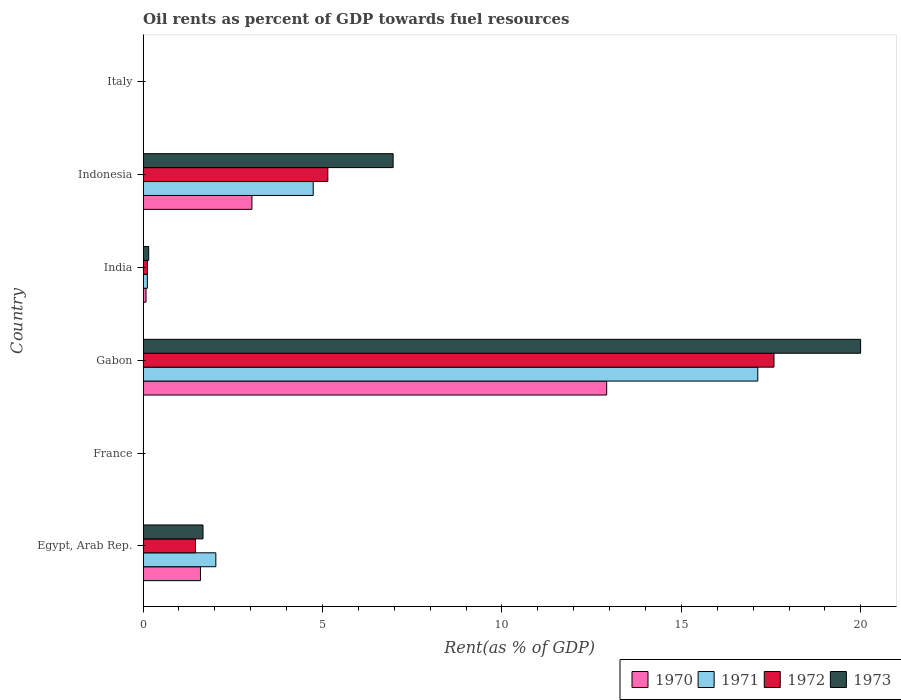How many groups of bars are there?
Your answer should be compact. 6. Are the number of bars on each tick of the Y-axis equal?
Your response must be concise. Yes. How many bars are there on the 3rd tick from the top?
Your answer should be very brief. 4. How many bars are there on the 6th tick from the bottom?
Offer a terse response. 4. What is the oil rent in 1970 in France?
Provide a succinct answer. 0.01. Across all countries, what is the maximum oil rent in 1971?
Your answer should be compact. 17.13. Across all countries, what is the minimum oil rent in 1970?
Give a very brief answer. 0.01. In which country was the oil rent in 1971 maximum?
Your answer should be very brief. Gabon. What is the total oil rent in 1971 in the graph?
Provide a short and direct response. 24.04. What is the difference between the oil rent in 1970 in France and that in Gabon?
Provide a succinct answer. -12.91. What is the difference between the oil rent in 1970 in Egypt, Arab Rep. and the oil rent in 1972 in Italy?
Offer a terse response. 1.59. What is the average oil rent in 1970 per country?
Your answer should be compact. 2.94. What is the difference between the oil rent in 1972 and oil rent in 1970 in Indonesia?
Make the answer very short. 2.11. What is the ratio of the oil rent in 1972 in Egypt, Arab Rep. to that in France?
Ensure brevity in your answer.  171.93. Is the oil rent in 1970 in India less than that in Indonesia?
Provide a succinct answer. Yes. Is the difference between the oil rent in 1972 in Egypt, Arab Rep. and France greater than the difference between the oil rent in 1970 in Egypt, Arab Rep. and France?
Offer a very short reply. No. What is the difference between the highest and the second highest oil rent in 1973?
Provide a short and direct response. 13.03. What is the difference between the highest and the lowest oil rent in 1970?
Your answer should be very brief. 12.91. What does the 4th bar from the top in Egypt, Arab Rep. represents?
Offer a terse response. 1970. Is it the case that in every country, the sum of the oil rent in 1970 and oil rent in 1971 is greater than the oil rent in 1972?
Your answer should be compact. Yes. Are all the bars in the graph horizontal?
Keep it short and to the point. Yes. How many countries are there in the graph?
Give a very brief answer. 6. What is the difference between two consecutive major ticks on the X-axis?
Ensure brevity in your answer.  5. Does the graph contain grids?
Provide a succinct answer. No. How many legend labels are there?
Your answer should be compact. 4. How are the legend labels stacked?
Your response must be concise. Horizontal. What is the title of the graph?
Your response must be concise. Oil rents as percent of GDP towards fuel resources. What is the label or title of the X-axis?
Your answer should be very brief. Rent(as % of GDP). What is the label or title of the Y-axis?
Provide a succinct answer. Country. What is the Rent(as % of GDP) of 1970 in Egypt, Arab Rep.?
Offer a very short reply. 1.6. What is the Rent(as % of GDP) in 1971 in Egypt, Arab Rep.?
Provide a short and direct response. 2.03. What is the Rent(as % of GDP) of 1972 in Egypt, Arab Rep.?
Make the answer very short. 1.46. What is the Rent(as % of GDP) in 1973 in Egypt, Arab Rep.?
Give a very brief answer. 1.67. What is the Rent(as % of GDP) of 1970 in France?
Ensure brevity in your answer.  0.01. What is the Rent(as % of GDP) in 1971 in France?
Offer a very short reply. 0.01. What is the Rent(as % of GDP) in 1972 in France?
Your response must be concise. 0.01. What is the Rent(as % of GDP) of 1973 in France?
Make the answer very short. 0.01. What is the Rent(as % of GDP) of 1970 in Gabon?
Provide a succinct answer. 12.92. What is the Rent(as % of GDP) in 1971 in Gabon?
Your answer should be compact. 17.13. What is the Rent(as % of GDP) in 1972 in Gabon?
Make the answer very short. 17.58. What is the Rent(as % of GDP) of 1973 in Gabon?
Give a very brief answer. 19.99. What is the Rent(as % of GDP) in 1970 in India?
Offer a very short reply. 0.08. What is the Rent(as % of GDP) of 1971 in India?
Ensure brevity in your answer.  0.12. What is the Rent(as % of GDP) of 1972 in India?
Provide a succinct answer. 0.12. What is the Rent(as % of GDP) in 1973 in India?
Make the answer very short. 0.16. What is the Rent(as % of GDP) in 1970 in Indonesia?
Offer a terse response. 3.03. What is the Rent(as % of GDP) of 1971 in Indonesia?
Offer a terse response. 4.74. What is the Rent(as % of GDP) of 1972 in Indonesia?
Provide a succinct answer. 5.15. What is the Rent(as % of GDP) of 1973 in Indonesia?
Your answer should be compact. 6.97. What is the Rent(as % of GDP) of 1970 in Italy?
Make the answer very short. 0.01. What is the Rent(as % of GDP) in 1971 in Italy?
Ensure brevity in your answer.  0.01. What is the Rent(as % of GDP) of 1972 in Italy?
Your answer should be compact. 0.01. What is the Rent(as % of GDP) of 1973 in Italy?
Keep it short and to the point. 0.01. Across all countries, what is the maximum Rent(as % of GDP) in 1970?
Keep it short and to the point. 12.92. Across all countries, what is the maximum Rent(as % of GDP) in 1971?
Provide a short and direct response. 17.13. Across all countries, what is the maximum Rent(as % of GDP) of 1972?
Offer a terse response. 17.58. Across all countries, what is the maximum Rent(as % of GDP) in 1973?
Provide a succinct answer. 19.99. Across all countries, what is the minimum Rent(as % of GDP) in 1970?
Your response must be concise. 0.01. Across all countries, what is the minimum Rent(as % of GDP) of 1971?
Your answer should be compact. 0.01. Across all countries, what is the minimum Rent(as % of GDP) of 1972?
Offer a terse response. 0.01. Across all countries, what is the minimum Rent(as % of GDP) of 1973?
Keep it short and to the point. 0.01. What is the total Rent(as % of GDP) of 1970 in the graph?
Give a very brief answer. 17.66. What is the total Rent(as % of GDP) of 1971 in the graph?
Offer a very short reply. 24.04. What is the total Rent(as % of GDP) in 1972 in the graph?
Give a very brief answer. 24.33. What is the total Rent(as % of GDP) of 1973 in the graph?
Make the answer very short. 28.81. What is the difference between the Rent(as % of GDP) of 1970 in Egypt, Arab Rep. and that in France?
Your answer should be compact. 1.59. What is the difference between the Rent(as % of GDP) of 1971 in Egypt, Arab Rep. and that in France?
Keep it short and to the point. 2.02. What is the difference between the Rent(as % of GDP) of 1972 in Egypt, Arab Rep. and that in France?
Your answer should be very brief. 1.45. What is the difference between the Rent(as % of GDP) in 1973 in Egypt, Arab Rep. and that in France?
Your answer should be very brief. 1.66. What is the difference between the Rent(as % of GDP) of 1970 in Egypt, Arab Rep. and that in Gabon?
Your response must be concise. -11.32. What is the difference between the Rent(as % of GDP) of 1971 in Egypt, Arab Rep. and that in Gabon?
Ensure brevity in your answer.  -15.1. What is the difference between the Rent(as % of GDP) of 1972 in Egypt, Arab Rep. and that in Gabon?
Keep it short and to the point. -16.12. What is the difference between the Rent(as % of GDP) in 1973 in Egypt, Arab Rep. and that in Gabon?
Ensure brevity in your answer.  -18.32. What is the difference between the Rent(as % of GDP) in 1970 in Egypt, Arab Rep. and that in India?
Your answer should be compact. 1.52. What is the difference between the Rent(as % of GDP) in 1971 in Egypt, Arab Rep. and that in India?
Provide a succinct answer. 1.91. What is the difference between the Rent(as % of GDP) in 1972 in Egypt, Arab Rep. and that in India?
Provide a short and direct response. 1.34. What is the difference between the Rent(as % of GDP) in 1973 in Egypt, Arab Rep. and that in India?
Ensure brevity in your answer.  1.51. What is the difference between the Rent(as % of GDP) in 1970 in Egypt, Arab Rep. and that in Indonesia?
Provide a succinct answer. -1.43. What is the difference between the Rent(as % of GDP) of 1971 in Egypt, Arab Rep. and that in Indonesia?
Your response must be concise. -2.71. What is the difference between the Rent(as % of GDP) in 1972 in Egypt, Arab Rep. and that in Indonesia?
Provide a short and direct response. -3.69. What is the difference between the Rent(as % of GDP) in 1973 in Egypt, Arab Rep. and that in Indonesia?
Make the answer very short. -5.3. What is the difference between the Rent(as % of GDP) in 1970 in Egypt, Arab Rep. and that in Italy?
Give a very brief answer. 1.59. What is the difference between the Rent(as % of GDP) in 1971 in Egypt, Arab Rep. and that in Italy?
Ensure brevity in your answer.  2.02. What is the difference between the Rent(as % of GDP) of 1972 in Egypt, Arab Rep. and that in Italy?
Provide a succinct answer. 1.45. What is the difference between the Rent(as % of GDP) of 1973 in Egypt, Arab Rep. and that in Italy?
Provide a short and direct response. 1.66. What is the difference between the Rent(as % of GDP) in 1970 in France and that in Gabon?
Ensure brevity in your answer.  -12.91. What is the difference between the Rent(as % of GDP) in 1971 in France and that in Gabon?
Provide a short and direct response. -17.12. What is the difference between the Rent(as % of GDP) in 1972 in France and that in Gabon?
Keep it short and to the point. -17.57. What is the difference between the Rent(as % of GDP) in 1973 in France and that in Gabon?
Your answer should be compact. -19.98. What is the difference between the Rent(as % of GDP) of 1970 in France and that in India?
Keep it short and to the point. -0.07. What is the difference between the Rent(as % of GDP) of 1971 in France and that in India?
Give a very brief answer. -0.11. What is the difference between the Rent(as % of GDP) in 1972 in France and that in India?
Make the answer very short. -0.11. What is the difference between the Rent(as % of GDP) in 1973 in France and that in India?
Provide a short and direct response. -0.15. What is the difference between the Rent(as % of GDP) of 1970 in France and that in Indonesia?
Your answer should be compact. -3.02. What is the difference between the Rent(as % of GDP) in 1971 in France and that in Indonesia?
Provide a short and direct response. -4.73. What is the difference between the Rent(as % of GDP) of 1972 in France and that in Indonesia?
Offer a very short reply. -5.14. What is the difference between the Rent(as % of GDP) of 1973 in France and that in Indonesia?
Make the answer very short. -6.96. What is the difference between the Rent(as % of GDP) in 1970 in France and that in Italy?
Your answer should be compact. 0. What is the difference between the Rent(as % of GDP) of 1971 in France and that in Italy?
Keep it short and to the point. 0. What is the difference between the Rent(as % of GDP) of 1972 in France and that in Italy?
Your response must be concise. -0. What is the difference between the Rent(as % of GDP) in 1973 in France and that in Italy?
Your response must be concise. -0. What is the difference between the Rent(as % of GDP) of 1970 in Gabon and that in India?
Your response must be concise. 12.84. What is the difference between the Rent(as % of GDP) in 1971 in Gabon and that in India?
Provide a short and direct response. 17.01. What is the difference between the Rent(as % of GDP) in 1972 in Gabon and that in India?
Keep it short and to the point. 17.46. What is the difference between the Rent(as % of GDP) of 1973 in Gabon and that in India?
Your answer should be compact. 19.84. What is the difference between the Rent(as % of GDP) in 1970 in Gabon and that in Indonesia?
Your response must be concise. 9.88. What is the difference between the Rent(as % of GDP) in 1971 in Gabon and that in Indonesia?
Offer a very short reply. 12.39. What is the difference between the Rent(as % of GDP) of 1972 in Gabon and that in Indonesia?
Give a very brief answer. 12.43. What is the difference between the Rent(as % of GDP) in 1973 in Gabon and that in Indonesia?
Your response must be concise. 13.03. What is the difference between the Rent(as % of GDP) in 1970 in Gabon and that in Italy?
Your answer should be compact. 12.91. What is the difference between the Rent(as % of GDP) in 1971 in Gabon and that in Italy?
Your answer should be compact. 17.12. What is the difference between the Rent(as % of GDP) in 1972 in Gabon and that in Italy?
Your answer should be very brief. 17.57. What is the difference between the Rent(as % of GDP) of 1973 in Gabon and that in Italy?
Your answer should be very brief. 19.98. What is the difference between the Rent(as % of GDP) in 1970 in India and that in Indonesia?
Your response must be concise. -2.95. What is the difference between the Rent(as % of GDP) in 1971 in India and that in Indonesia?
Make the answer very short. -4.62. What is the difference between the Rent(as % of GDP) in 1972 in India and that in Indonesia?
Make the answer very short. -5.03. What is the difference between the Rent(as % of GDP) in 1973 in India and that in Indonesia?
Your answer should be very brief. -6.81. What is the difference between the Rent(as % of GDP) in 1970 in India and that in Italy?
Ensure brevity in your answer.  0.07. What is the difference between the Rent(as % of GDP) in 1971 in India and that in Italy?
Your answer should be compact. 0.11. What is the difference between the Rent(as % of GDP) of 1972 in India and that in Italy?
Provide a succinct answer. 0.11. What is the difference between the Rent(as % of GDP) of 1973 in India and that in Italy?
Make the answer very short. 0.15. What is the difference between the Rent(as % of GDP) of 1970 in Indonesia and that in Italy?
Provide a short and direct response. 3.02. What is the difference between the Rent(as % of GDP) of 1971 in Indonesia and that in Italy?
Ensure brevity in your answer.  4.73. What is the difference between the Rent(as % of GDP) of 1972 in Indonesia and that in Italy?
Provide a short and direct response. 5.14. What is the difference between the Rent(as % of GDP) in 1973 in Indonesia and that in Italy?
Provide a short and direct response. 6.96. What is the difference between the Rent(as % of GDP) in 1970 in Egypt, Arab Rep. and the Rent(as % of GDP) in 1971 in France?
Give a very brief answer. 1.59. What is the difference between the Rent(as % of GDP) of 1970 in Egypt, Arab Rep. and the Rent(as % of GDP) of 1972 in France?
Your answer should be compact. 1.59. What is the difference between the Rent(as % of GDP) in 1970 in Egypt, Arab Rep. and the Rent(as % of GDP) in 1973 in France?
Give a very brief answer. 1.59. What is the difference between the Rent(as % of GDP) in 1971 in Egypt, Arab Rep. and the Rent(as % of GDP) in 1972 in France?
Provide a succinct answer. 2.02. What is the difference between the Rent(as % of GDP) in 1971 in Egypt, Arab Rep. and the Rent(as % of GDP) in 1973 in France?
Your answer should be compact. 2.02. What is the difference between the Rent(as % of GDP) in 1972 in Egypt, Arab Rep. and the Rent(as % of GDP) in 1973 in France?
Make the answer very short. 1.45. What is the difference between the Rent(as % of GDP) of 1970 in Egypt, Arab Rep. and the Rent(as % of GDP) of 1971 in Gabon?
Keep it short and to the point. -15.53. What is the difference between the Rent(as % of GDP) of 1970 in Egypt, Arab Rep. and the Rent(as % of GDP) of 1972 in Gabon?
Keep it short and to the point. -15.98. What is the difference between the Rent(as % of GDP) of 1970 in Egypt, Arab Rep. and the Rent(as % of GDP) of 1973 in Gabon?
Your answer should be very brief. -18.39. What is the difference between the Rent(as % of GDP) in 1971 in Egypt, Arab Rep. and the Rent(as % of GDP) in 1972 in Gabon?
Ensure brevity in your answer.  -15.55. What is the difference between the Rent(as % of GDP) of 1971 in Egypt, Arab Rep. and the Rent(as % of GDP) of 1973 in Gabon?
Provide a short and direct response. -17.97. What is the difference between the Rent(as % of GDP) in 1972 in Egypt, Arab Rep. and the Rent(as % of GDP) in 1973 in Gabon?
Provide a succinct answer. -18.53. What is the difference between the Rent(as % of GDP) in 1970 in Egypt, Arab Rep. and the Rent(as % of GDP) in 1971 in India?
Ensure brevity in your answer.  1.48. What is the difference between the Rent(as % of GDP) in 1970 in Egypt, Arab Rep. and the Rent(as % of GDP) in 1972 in India?
Provide a short and direct response. 1.48. What is the difference between the Rent(as % of GDP) in 1970 in Egypt, Arab Rep. and the Rent(as % of GDP) in 1973 in India?
Offer a terse response. 1.44. What is the difference between the Rent(as % of GDP) in 1971 in Egypt, Arab Rep. and the Rent(as % of GDP) in 1972 in India?
Your answer should be very brief. 1.91. What is the difference between the Rent(as % of GDP) in 1971 in Egypt, Arab Rep. and the Rent(as % of GDP) in 1973 in India?
Your answer should be very brief. 1.87. What is the difference between the Rent(as % of GDP) of 1972 in Egypt, Arab Rep. and the Rent(as % of GDP) of 1973 in India?
Ensure brevity in your answer.  1.3. What is the difference between the Rent(as % of GDP) in 1970 in Egypt, Arab Rep. and the Rent(as % of GDP) in 1971 in Indonesia?
Give a very brief answer. -3.14. What is the difference between the Rent(as % of GDP) of 1970 in Egypt, Arab Rep. and the Rent(as % of GDP) of 1972 in Indonesia?
Your answer should be very brief. -3.55. What is the difference between the Rent(as % of GDP) in 1970 in Egypt, Arab Rep. and the Rent(as % of GDP) in 1973 in Indonesia?
Ensure brevity in your answer.  -5.37. What is the difference between the Rent(as % of GDP) of 1971 in Egypt, Arab Rep. and the Rent(as % of GDP) of 1972 in Indonesia?
Your response must be concise. -3.12. What is the difference between the Rent(as % of GDP) in 1971 in Egypt, Arab Rep. and the Rent(as % of GDP) in 1973 in Indonesia?
Give a very brief answer. -4.94. What is the difference between the Rent(as % of GDP) in 1972 in Egypt, Arab Rep. and the Rent(as % of GDP) in 1973 in Indonesia?
Your answer should be very brief. -5.51. What is the difference between the Rent(as % of GDP) in 1970 in Egypt, Arab Rep. and the Rent(as % of GDP) in 1971 in Italy?
Ensure brevity in your answer.  1.59. What is the difference between the Rent(as % of GDP) in 1970 in Egypt, Arab Rep. and the Rent(as % of GDP) in 1972 in Italy?
Give a very brief answer. 1.59. What is the difference between the Rent(as % of GDP) of 1970 in Egypt, Arab Rep. and the Rent(as % of GDP) of 1973 in Italy?
Offer a very short reply. 1.59. What is the difference between the Rent(as % of GDP) of 1971 in Egypt, Arab Rep. and the Rent(as % of GDP) of 1972 in Italy?
Offer a terse response. 2.02. What is the difference between the Rent(as % of GDP) of 1971 in Egypt, Arab Rep. and the Rent(as % of GDP) of 1973 in Italy?
Your response must be concise. 2.02. What is the difference between the Rent(as % of GDP) of 1972 in Egypt, Arab Rep. and the Rent(as % of GDP) of 1973 in Italy?
Make the answer very short. 1.45. What is the difference between the Rent(as % of GDP) in 1970 in France and the Rent(as % of GDP) in 1971 in Gabon?
Offer a very short reply. -17.12. What is the difference between the Rent(as % of GDP) of 1970 in France and the Rent(as % of GDP) of 1972 in Gabon?
Ensure brevity in your answer.  -17.57. What is the difference between the Rent(as % of GDP) of 1970 in France and the Rent(as % of GDP) of 1973 in Gabon?
Your answer should be compact. -19.98. What is the difference between the Rent(as % of GDP) in 1971 in France and the Rent(as % of GDP) in 1972 in Gabon?
Ensure brevity in your answer.  -17.57. What is the difference between the Rent(as % of GDP) of 1971 in France and the Rent(as % of GDP) of 1973 in Gabon?
Your response must be concise. -19.98. What is the difference between the Rent(as % of GDP) of 1972 in France and the Rent(as % of GDP) of 1973 in Gabon?
Ensure brevity in your answer.  -19.99. What is the difference between the Rent(as % of GDP) in 1970 in France and the Rent(as % of GDP) in 1971 in India?
Make the answer very short. -0.11. What is the difference between the Rent(as % of GDP) in 1970 in France and the Rent(as % of GDP) in 1972 in India?
Give a very brief answer. -0.11. What is the difference between the Rent(as % of GDP) of 1970 in France and the Rent(as % of GDP) of 1973 in India?
Your answer should be compact. -0.15. What is the difference between the Rent(as % of GDP) in 1971 in France and the Rent(as % of GDP) in 1972 in India?
Your answer should be very brief. -0.11. What is the difference between the Rent(as % of GDP) in 1971 in France and the Rent(as % of GDP) in 1973 in India?
Offer a terse response. -0.14. What is the difference between the Rent(as % of GDP) of 1972 in France and the Rent(as % of GDP) of 1973 in India?
Your response must be concise. -0.15. What is the difference between the Rent(as % of GDP) of 1970 in France and the Rent(as % of GDP) of 1971 in Indonesia?
Ensure brevity in your answer.  -4.73. What is the difference between the Rent(as % of GDP) in 1970 in France and the Rent(as % of GDP) in 1972 in Indonesia?
Offer a very short reply. -5.14. What is the difference between the Rent(as % of GDP) in 1970 in France and the Rent(as % of GDP) in 1973 in Indonesia?
Provide a short and direct response. -6.96. What is the difference between the Rent(as % of GDP) in 1971 in France and the Rent(as % of GDP) in 1972 in Indonesia?
Your answer should be very brief. -5.14. What is the difference between the Rent(as % of GDP) in 1971 in France and the Rent(as % of GDP) in 1973 in Indonesia?
Give a very brief answer. -6.96. What is the difference between the Rent(as % of GDP) of 1972 in France and the Rent(as % of GDP) of 1973 in Indonesia?
Provide a short and direct response. -6.96. What is the difference between the Rent(as % of GDP) of 1970 in France and the Rent(as % of GDP) of 1971 in Italy?
Your answer should be compact. -0. What is the difference between the Rent(as % of GDP) in 1970 in France and the Rent(as % of GDP) in 1972 in Italy?
Offer a terse response. 0. What is the difference between the Rent(as % of GDP) in 1970 in France and the Rent(as % of GDP) in 1973 in Italy?
Keep it short and to the point. 0. What is the difference between the Rent(as % of GDP) of 1971 in France and the Rent(as % of GDP) of 1972 in Italy?
Your response must be concise. 0. What is the difference between the Rent(as % of GDP) in 1971 in France and the Rent(as % of GDP) in 1973 in Italy?
Give a very brief answer. 0. What is the difference between the Rent(as % of GDP) in 1972 in France and the Rent(as % of GDP) in 1973 in Italy?
Provide a succinct answer. -0. What is the difference between the Rent(as % of GDP) of 1970 in Gabon and the Rent(as % of GDP) of 1971 in India?
Offer a terse response. 12.8. What is the difference between the Rent(as % of GDP) of 1970 in Gabon and the Rent(as % of GDP) of 1972 in India?
Offer a terse response. 12.8. What is the difference between the Rent(as % of GDP) of 1970 in Gabon and the Rent(as % of GDP) of 1973 in India?
Offer a very short reply. 12.76. What is the difference between the Rent(as % of GDP) in 1971 in Gabon and the Rent(as % of GDP) in 1972 in India?
Provide a short and direct response. 17.01. What is the difference between the Rent(as % of GDP) in 1971 in Gabon and the Rent(as % of GDP) in 1973 in India?
Make the answer very short. 16.97. What is the difference between the Rent(as % of GDP) in 1972 in Gabon and the Rent(as % of GDP) in 1973 in India?
Ensure brevity in your answer.  17.42. What is the difference between the Rent(as % of GDP) in 1970 in Gabon and the Rent(as % of GDP) in 1971 in Indonesia?
Offer a terse response. 8.18. What is the difference between the Rent(as % of GDP) of 1970 in Gabon and the Rent(as % of GDP) of 1972 in Indonesia?
Offer a terse response. 7.77. What is the difference between the Rent(as % of GDP) in 1970 in Gabon and the Rent(as % of GDP) in 1973 in Indonesia?
Provide a short and direct response. 5.95. What is the difference between the Rent(as % of GDP) of 1971 in Gabon and the Rent(as % of GDP) of 1972 in Indonesia?
Provide a short and direct response. 11.98. What is the difference between the Rent(as % of GDP) in 1971 in Gabon and the Rent(as % of GDP) in 1973 in Indonesia?
Provide a succinct answer. 10.16. What is the difference between the Rent(as % of GDP) of 1972 in Gabon and the Rent(as % of GDP) of 1973 in Indonesia?
Offer a very short reply. 10.61. What is the difference between the Rent(as % of GDP) of 1970 in Gabon and the Rent(as % of GDP) of 1971 in Italy?
Offer a terse response. 12.91. What is the difference between the Rent(as % of GDP) of 1970 in Gabon and the Rent(as % of GDP) of 1972 in Italy?
Provide a short and direct response. 12.91. What is the difference between the Rent(as % of GDP) in 1970 in Gabon and the Rent(as % of GDP) in 1973 in Italy?
Ensure brevity in your answer.  12.91. What is the difference between the Rent(as % of GDP) of 1971 in Gabon and the Rent(as % of GDP) of 1972 in Italy?
Ensure brevity in your answer.  17.12. What is the difference between the Rent(as % of GDP) in 1971 in Gabon and the Rent(as % of GDP) in 1973 in Italy?
Provide a short and direct response. 17.12. What is the difference between the Rent(as % of GDP) of 1972 in Gabon and the Rent(as % of GDP) of 1973 in Italy?
Provide a short and direct response. 17.57. What is the difference between the Rent(as % of GDP) of 1970 in India and the Rent(as % of GDP) of 1971 in Indonesia?
Give a very brief answer. -4.66. What is the difference between the Rent(as % of GDP) of 1970 in India and the Rent(as % of GDP) of 1972 in Indonesia?
Make the answer very short. -5.07. What is the difference between the Rent(as % of GDP) of 1970 in India and the Rent(as % of GDP) of 1973 in Indonesia?
Provide a succinct answer. -6.89. What is the difference between the Rent(as % of GDP) of 1971 in India and the Rent(as % of GDP) of 1972 in Indonesia?
Ensure brevity in your answer.  -5.03. What is the difference between the Rent(as % of GDP) of 1971 in India and the Rent(as % of GDP) of 1973 in Indonesia?
Offer a terse response. -6.85. What is the difference between the Rent(as % of GDP) of 1972 in India and the Rent(as % of GDP) of 1973 in Indonesia?
Your answer should be compact. -6.85. What is the difference between the Rent(as % of GDP) of 1970 in India and the Rent(as % of GDP) of 1971 in Italy?
Your response must be concise. 0.07. What is the difference between the Rent(as % of GDP) in 1970 in India and the Rent(as % of GDP) in 1972 in Italy?
Offer a very short reply. 0.07. What is the difference between the Rent(as % of GDP) of 1970 in India and the Rent(as % of GDP) of 1973 in Italy?
Your answer should be very brief. 0.07. What is the difference between the Rent(as % of GDP) in 1971 in India and the Rent(as % of GDP) in 1972 in Italy?
Your answer should be very brief. 0.11. What is the difference between the Rent(as % of GDP) of 1971 in India and the Rent(as % of GDP) of 1973 in Italy?
Ensure brevity in your answer.  0.11. What is the difference between the Rent(as % of GDP) of 1972 in India and the Rent(as % of GDP) of 1973 in Italy?
Offer a terse response. 0.11. What is the difference between the Rent(as % of GDP) of 1970 in Indonesia and the Rent(as % of GDP) of 1971 in Italy?
Offer a very short reply. 3.02. What is the difference between the Rent(as % of GDP) of 1970 in Indonesia and the Rent(as % of GDP) of 1972 in Italy?
Ensure brevity in your answer.  3.02. What is the difference between the Rent(as % of GDP) of 1970 in Indonesia and the Rent(as % of GDP) of 1973 in Italy?
Provide a succinct answer. 3.02. What is the difference between the Rent(as % of GDP) in 1971 in Indonesia and the Rent(as % of GDP) in 1972 in Italy?
Give a very brief answer. 4.73. What is the difference between the Rent(as % of GDP) of 1971 in Indonesia and the Rent(as % of GDP) of 1973 in Italy?
Offer a terse response. 4.73. What is the difference between the Rent(as % of GDP) of 1972 in Indonesia and the Rent(as % of GDP) of 1973 in Italy?
Offer a terse response. 5.14. What is the average Rent(as % of GDP) of 1970 per country?
Offer a terse response. 2.94. What is the average Rent(as % of GDP) in 1971 per country?
Provide a succinct answer. 4.01. What is the average Rent(as % of GDP) of 1972 per country?
Keep it short and to the point. 4.05. What is the average Rent(as % of GDP) in 1973 per country?
Your answer should be very brief. 4.8. What is the difference between the Rent(as % of GDP) of 1970 and Rent(as % of GDP) of 1971 in Egypt, Arab Rep.?
Give a very brief answer. -0.43. What is the difference between the Rent(as % of GDP) of 1970 and Rent(as % of GDP) of 1972 in Egypt, Arab Rep.?
Make the answer very short. 0.14. What is the difference between the Rent(as % of GDP) in 1970 and Rent(as % of GDP) in 1973 in Egypt, Arab Rep.?
Your answer should be very brief. -0.07. What is the difference between the Rent(as % of GDP) in 1971 and Rent(as % of GDP) in 1972 in Egypt, Arab Rep.?
Your answer should be very brief. 0.57. What is the difference between the Rent(as % of GDP) in 1971 and Rent(as % of GDP) in 1973 in Egypt, Arab Rep.?
Offer a terse response. 0.36. What is the difference between the Rent(as % of GDP) in 1972 and Rent(as % of GDP) in 1973 in Egypt, Arab Rep.?
Provide a short and direct response. -0.21. What is the difference between the Rent(as % of GDP) in 1970 and Rent(as % of GDP) in 1971 in France?
Give a very brief answer. -0. What is the difference between the Rent(as % of GDP) in 1970 and Rent(as % of GDP) in 1972 in France?
Make the answer very short. 0. What is the difference between the Rent(as % of GDP) in 1970 and Rent(as % of GDP) in 1973 in France?
Your response must be concise. 0. What is the difference between the Rent(as % of GDP) in 1971 and Rent(as % of GDP) in 1972 in France?
Ensure brevity in your answer.  0. What is the difference between the Rent(as % of GDP) of 1971 and Rent(as % of GDP) of 1973 in France?
Provide a succinct answer. 0. What is the difference between the Rent(as % of GDP) in 1972 and Rent(as % of GDP) in 1973 in France?
Your answer should be very brief. -0. What is the difference between the Rent(as % of GDP) in 1970 and Rent(as % of GDP) in 1971 in Gabon?
Your response must be concise. -4.21. What is the difference between the Rent(as % of GDP) in 1970 and Rent(as % of GDP) in 1972 in Gabon?
Keep it short and to the point. -4.66. What is the difference between the Rent(as % of GDP) in 1970 and Rent(as % of GDP) in 1973 in Gabon?
Provide a succinct answer. -7.08. What is the difference between the Rent(as % of GDP) of 1971 and Rent(as % of GDP) of 1972 in Gabon?
Your answer should be compact. -0.45. What is the difference between the Rent(as % of GDP) in 1971 and Rent(as % of GDP) in 1973 in Gabon?
Your response must be concise. -2.87. What is the difference between the Rent(as % of GDP) in 1972 and Rent(as % of GDP) in 1973 in Gabon?
Your response must be concise. -2.41. What is the difference between the Rent(as % of GDP) of 1970 and Rent(as % of GDP) of 1971 in India?
Give a very brief answer. -0.04. What is the difference between the Rent(as % of GDP) of 1970 and Rent(as % of GDP) of 1972 in India?
Your response must be concise. -0.04. What is the difference between the Rent(as % of GDP) of 1970 and Rent(as % of GDP) of 1973 in India?
Keep it short and to the point. -0.07. What is the difference between the Rent(as % of GDP) in 1971 and Rent(as % of GDP) in 1972 in India?
Your answer should be very brief. -0. What is the difference between the Rent(as % of GDP) of 1971 and Rent(as % of GDP) of 1973 in India?
Provide a short and direct response. -0.04. What is the difference between the Rent(as % of GDP) of 1972 and Rent(as % of GDP) of 1973 in India?
Give a very brief answer. -0.04. What is the difference between the Rent(as % of GDP) in 1970 and Rent(as % of GDP) in 1971 in Indonesia?
Your answer should be very brief. -1.71. What is the difference between the Rent(as % of GDP) in 1970 and Rent(as % of GDP) in 1972 in Indonesia?
Keep it short and to the point. -2.11. What is the difference between the Rent(as % of GDP) of 1970 and Rent(as % of GDP) of 1973 in Indonesia?
Make the answer very short. -3.93. What is the difference between the Rent(as % of GDP) of 1971 and Rent(as % of GDP) of 1972 in Indonesia?
Make the answer very short. -0.41. What is the difference between the Rent(as % of GDP) in 1971 and Rent(as % of GDP) in 1973 in Indonesia?
Your response must be concise. -2.23. What is the difference between the Rent(as % of GDP) in 1972 and Rent(as % of GDP) in 1973 in Indonesia?
Your answer should be compact. -1.82. What is the difference between the Rent(as % of GDP) in 1970 and Rent(as % of GDP) in 1971 in Italy?
Provide a succinct answer. -0. What is the difference between the Rent(as % of GDP) in 1970 and Rent(as % of GDP) in 1972 in Italy?
Keep it short and to the point. 0. What is the difference between the Rent(as % of GDP) of 1970 and Rent(as % of GDP) of 1973 in Italy?
Offer a terse response. -0. What is the difference between the Rent(as % of GDP) in 1971 and Rent(as % of GDP) in 1972 in Italy?
Give a very brief answer. 0. What is the difference between the Rent(as % of GDP) in 1972 and Rent(as % of GDP) in 1973 in Italy?
Give a very brief answer. -0. What is the ratio of the Rent(as % of GDP) in 1970 in Egypt, Arab Rep. to that in France?
Your response must be concise. 139.1. What is the ratio of the Rent(as % of GDP) in 1971 in Egypt, Arab Rep. to that in France?
Make the answer very short. 164.4. What is the ratio of the Rent(as % of GDP) in 1972 in Egypt, Arab Rep. to that in France?
Offer a terse response. 171.93. What is the ratio of the Rent(as % of GDP) of 1973 in Egypt, Arab Rep. to that in France?
Offer a terse response. 189.03. What is the ratio of the Rent(as % of GDP) in 1970 in Egypt, Arab Rep. to that in Gabon?
Your response must be concise. 0.12. What is the ratio of the Rent(as % of GDP) in 1971 in Egypt, Arab Rep. to that in Gabon?
Provide a short and direct response. 0.12. What is the ratio of the Rent(as % of GDP) in 1972 in Egypt, Arab Rep. to that in Gabon?
Your answer should be compact. 0.08. What is the ratio of the Rent(as % of GDP) in 1973 in Egypt, Arab Rep. to that in Gabon?
Your answer should be very brief. 0.08. What is the ratio of the Rent(as % of GDP) in 1970 in Egypt, Arab Rep. to that in India?
Provide a short and direct response. 19.39. What is the ratio of the Rent(as % of GDP) of 1971 in Egypt, Arab Rep. to that in India?
Give a very brief answer. 16.93. What is the ratio of the Rent(as % of GDP) in 1972 in Egypt, Arab Rep. to that in India?
Ensure brevity in your answer.  12.16. What is the ratio of the Rent(as % of GDP) of 1973 in Egypt, Arab Rep. to that in India?
Your answer should be very brief. 10.63. What is the ratio of the Rent(as % of GDP) of 1970 in Egypt, Arab Rep. to that in Indonesia?
Provide a succinct answer. 0.53. What is the ratio of the Rent(as % of GDP) in 1971 in Egypt, Arab Rep. to that in Indonesia?
Provide a short and direct response. 0.43. What is the ratio of the Rent(as % of GDP) in 1972 in Egypt, Arab Rep. to that in Indonesia?
Give a very brief answer. 0.28. What is the ratio of the Rent(as % of GDP) of 1973 in Egypt, Arab Rep. to that in Indonesia?
Provide a succinct answer. 0.24. What is the ratio of the Rent(as % of GDP) in 1970 in Egypt, Arab Rep. to that in Italy?
Your answer should be very brief. 162.31. What is the ratio of the Rent(as % of GDP) in 1971 in Egypt, Arab Rep. to that in Italy?
Your answer should be compact. 173.07. What is the ratio of the Rent(as % of GDP) of 1972 in Egypt, Arab Rep. to that in Italy?
Offer a terse response. 157.02. What is the ratio of the Rent(as % of GDP) in 1973 in Egypt, Arab Rep. to that in Italy?
Offer a terse response. 149.13. What is the ratio of the Rent(as % of GDP) in 1970 in France to that in Gabon?
Ensure brevity in your answer.  0. What is the ratio of the Rent(as % of GDP) of 1971 in France to that in Gabon?
Provide a short and direct response. 0. What is the ratio of the Rent(as % of GDP) in 1972 in France to that in Gabon?
Provide a succinct answer. 0. What is the ratio of the Rent(as % of GDP) in 1970 in France to that in India?
Ensure brevity in your answer.  0.14. What is the ratio of the Rent(as % of GDP) of 1971 in France to that in India?
Ensure brevity in your answer.  0.1. What is the ratio of the Rent(as % of GDP) in 1972 in France to that in India?
Your response must be concise. 0.07. What is the ratio of the Rent(as % of GDP) of 1973 in France to that in India?
Ensure brevity in your answer.  0.06. What is the ratio of the Rent(as % of GDP) of 1970 in France to that in Indonesia?
Make the answer very short. 0. What is the ratio of the Rent(as % of GDP) of 1971 in France to that in Indonesia?
Your answer should be compact. 0. What is the ratio of the Rent(as % of GDP) of 1972 in France to that in Indonesia?
Your response must be concise. 0. What is the ratio of the Rent(as % of GDP) in 1973 in France to that in Indonesia?
Keep it short and to the point. 0. What is the ratio of the Rent(as % of GDP) in 1970 in France to that in Italy?
Provide a short and direct response. 1.17. What is the ratio of the Rent(as % of GDP) in 1971 in France to that in Italy?
Give a very brief answer. 1.05. What is the ratio of the Rent(as % of GDP) in 1972 in France to that in Italy?
Provide a short and direct response. 0.91. What is the ratio of the Rent(as % of GDP) in 1973 in France to that in Italy?
Offer a very short reply. 0.79. What is the ratio of the Rent(as % of GDP) in 1970 in Gabon to that in India?
Make the answer very short. 156.62. What is the ratio of the Rent(as % of GDP) of 1971 in Gabon to that in India?
Give a very brief answer. 142.99. What is the ratio of the Rent(as % of GDP) of 1972 in Gabon to that in India?
Provide a short and direct response. 146.29. What is the ratio of the Rent(as % of GDP) in 1973 in Gabon to that in India?
Make the answer very short. 127.16. What is the ratio of the Rent(as % of GDP) of 1970 in Gabon to that in Indonesia?
Offer a terse response. 4.26. What is the ratio of the Rent(as % of GDP) in 1971 in Gabon to that in Indonesia?
Offer a very short reply. 3.61. What is the ratio of the Rent(as % of GDP) in 1972 in Gabon to that in Indonesia?
Your answer should be very brief. 3.41. What is the ratio of the Rent(as % of GDP) in 1973 in Gabon to that in Indonesia?
Make the answer very short. 2.87. What is the ratio of the Rent(as % of GDP) in 1970 in Gabon to that in Italy?
Keep it short and to the point. 1310.76. What is the ratio of the Rent(as % of GDP) of 1971 in Gabon to that in Italy?
Offer a very short reply. 1461.71. What is the ratio of the Rent(as % of GDP) of 1972 in Gabon to that in Italy?
Make the answer very short. 1889.75. What is the ratio of the Rent(as % of GDP) of 1973 in Gabon to that in Italy?
Offer a very short reply. 1784.8. What is the ratio of the Rent(as % of GDP) of 1970 in India to that in Indonesia?
Your response must be concise. 0.03. What is the ratio of the Rent(as % of GDP) in 1971 in India to that in Indonesia?
Your response must be concise. 0.03. What is the ratio of the Rent(as % of GDP) of 1972 in India to that in Indonesia?
Provide a short and direct response. 0.02. What is the ratio of the Rent(as % of GDP) of 1973 in India to that in Indonesia?
Offer a very short reply. 0.02. What is the ratio of the Rent(as % of GDP) in 1970 in India to that in Italy?
Make the answer very short. 8.37. What is the ratio of the Rent(as % of GDP) of 1971 in India to that in Italy?
Keep it short and to the point. 10.22. What is the ratio of the Rent(as % of GDP) of 1972 in India to that in Italy?
Make the answer very short. 12.92. What is the ratio of the Rent(as % of GDP) in 1973 in India to that in Italy?
Provide a short and direct response. 14.04. What is the ratio of the Rent(as % of GDP) of 1970 in Indonesia to that in Italy?
Make the answer very short. 307.81. What is the ratio of the Rent(as % of GDP) in 1971 in Indonesia to that in Italy?
Give a very brief answer. 404.61. What is the ratio of the Rent(as % of GDP) in 1972 in Indonesia to that in Italy?
Ensure brevity in your answer.  553.4. What is the ratio of the Rent(as % of GDP) in 1973 in Indonesia to that in Italy?
Give a very brief answer. 622.04. What is the difference between the highest and the second highest Rent(as % of GDP) of 1970?
Offer a terse response. 9.88. What is the difference between the highest and the second highest Rent(as % of GDP) in 1971?
Your response must be concise. 12.39. What is the difference between the highest and the second highest Rent(as % of GDP) of 1972?
Ensure brevity in your answer.  12.43. What is the difference between the highest and the second highest Rent(as % of GDP) in 1973?
Make the answer very short. 13.03. What is the difference between the highest and the lowest Rent(as % of GDP) in 1970?
Offer a very short reply. 12.91. What is the difference between the highest and the lowest Rent(as % of GDP) of 1971?
Give a very brief answer. 17.12. What is the difference between the highest and the lowest Rent(as % of GDP) of 1972?
Your answer should be compact. 17.57. What is the difference between the highest and the lowest Rent(as % of GDP) in 1973?
Offer a terse response. 19.98. 